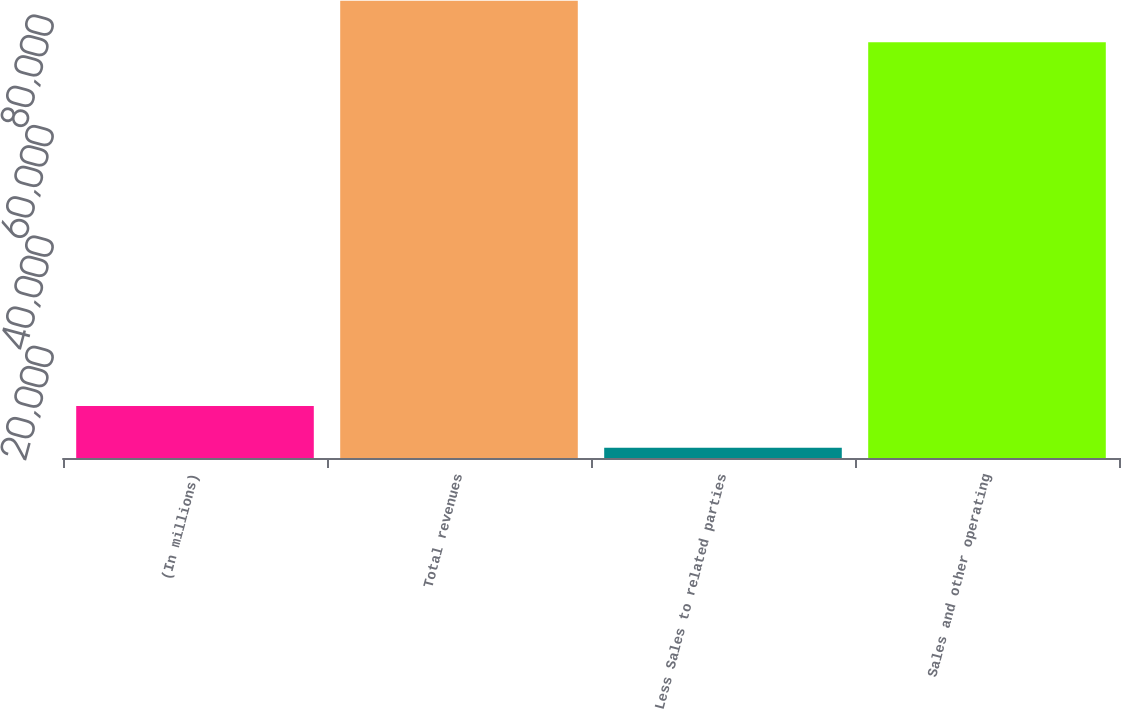<chart> <loc_0><loc_0><loc_500><loc_500><bar_chart><fcel>(In millions)<fcel>Total revenues<fcel>Less Sales to related parties<fcel>Sales and other operating<nl><fcel>9410.4<fcel>82845.4<fcel>1879<fcel>75314<nl></chart> 